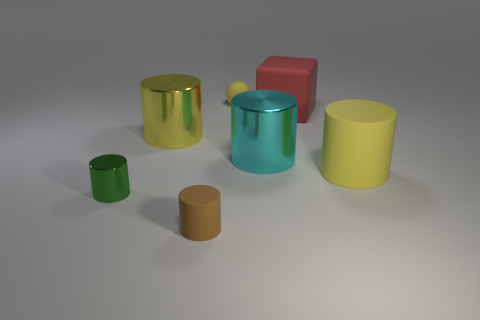What is the size relationship between the green and yellow objects? The green objects include one small matte ball and a larger cylinder. The yellow objects consist of a large, shiny cylinder. Comparatively, the large yellow cylinder is the biggest among these, followed by the green cylinder, then the small green ball. 